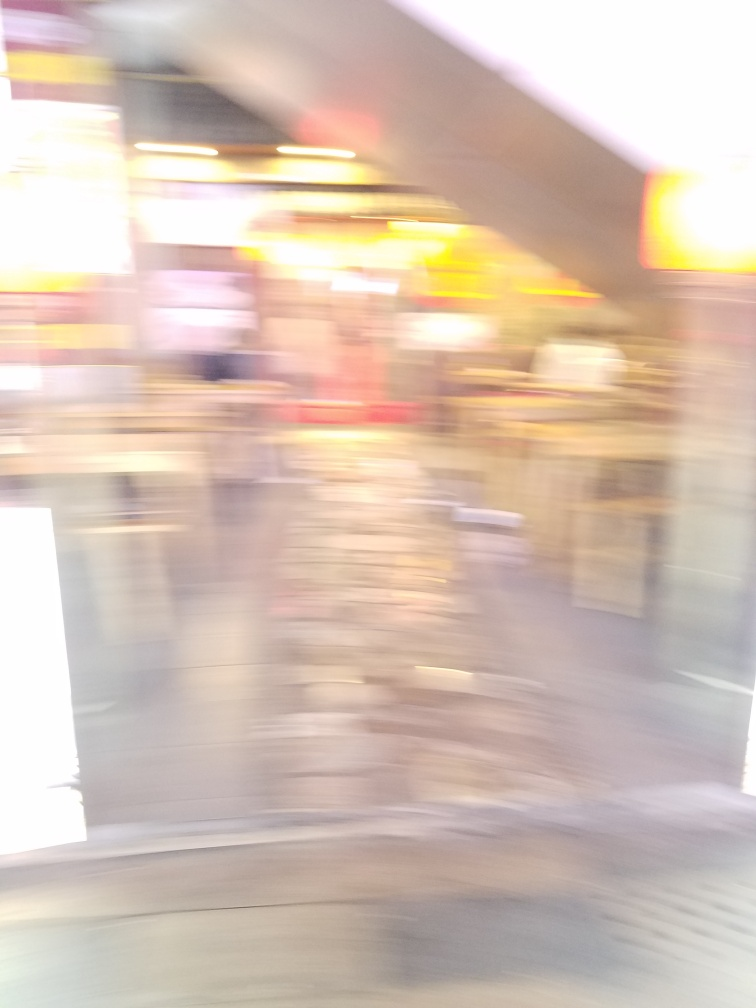What emotions does the blurriness of the image evoke? The blurriness can evoke a sense of motion, haste, or chaos, possibly overwhelming or disorienting to the viewer. It may also bring about feelings of nostalgia or whimsy, as it distorts reality, giving the scene an impressionistic and dream-like quality. Could this kind of image be used artistically or stylistically, and how? Absolutely, this type of image can be used to great effect in artistic contexts. It can underscore themes of movement or the passage of time in visual art. In storytelling, such a picture could represent a character's mental state, such as confusion or memory loss. Photographers and artists sometimes intentionally use blurriness to create a sense of action or to draw the viewer's focus to the mood rather than the details of a scene. 